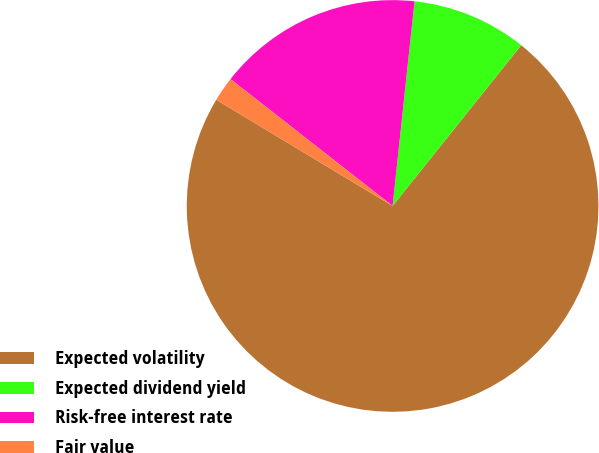Convert chart. <chart><loc_0><loc_0><loc_500><loc_500><pie_chart><fcel>Expected volatility<fcel>Expected dividend yield<fcel>Risk-free interest rate<fcel>Fair value<nl><fcel>72.89%<fcel>9.04%<fcel>16.13%<fcel>1.94%<nl></chart> 